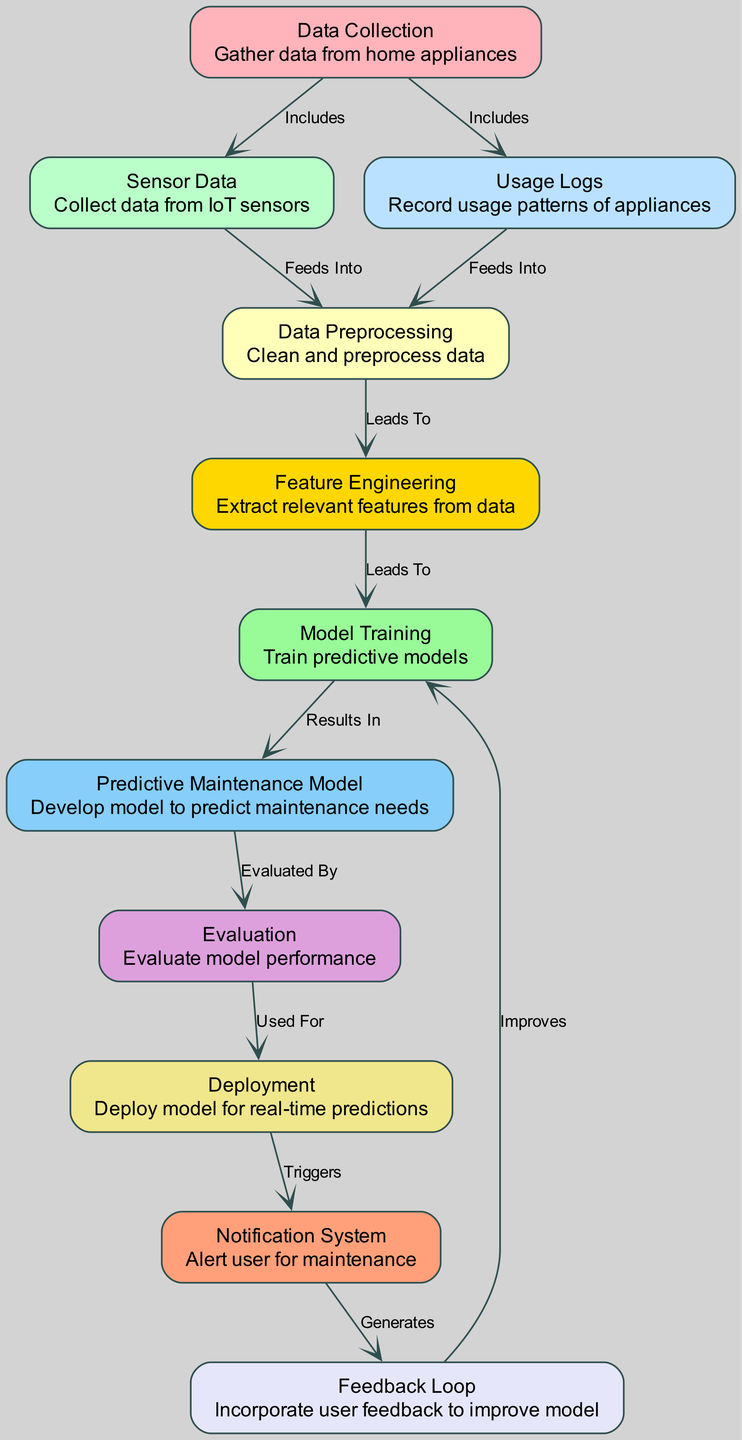What is the first step in the process? The first step in the diagram is labeled "Data Collection," which is where data is gathered from home appliances.
Answer: Data Collection How many nodes are exclusively related to data collection? The nodes "Sensor Data" and "Usage Logs" are both included under "Data Collection," indicating they are specifically related. Counting these gives us a total of two nodes.
Answer: 2 What does the "Data Preprocessing" node lead to? The diagram indicates that the "Data Preprocessing" node leads to the "Feature Engineering" node, meaning that after data is cleaned and preprocessed, the relevant features are extracted next.
Answer: Feature Engineering Which node evaluates the model performance? The "Evaluation" node is designated as the one that evaluates the performance of the predictive maintenance model according to the diagram.
Answer: Evaluation What triggers the notification system? The "Deployment" node triggers the "Notification System," indicating that once the model is deployed, the system will send alerts for maintenance needs.
Answer: Deployment Which two nodes feed into the "Data Preprocessing" node? The "Sensor Data" and "Usage Logs" nodes both feed into the "Data Preprocessing" node, meaning data from these sources is used for cleaning and preparation.
Answer: Sensor Data, Usage Logs How does the feedback loop impact model training? The "Feedback Loop" node improves the "Model Training" node, meaning the feedback received from users is utilized to enhance the predictive models over time.
Answer: Improves What is the output of the predictive maintenance model? The output is the "Predictive Maintenance Model," which develops predictions for when maintenance is needed based on the trained models.
Answer: Predictive Maintenance Model Which process involves cleaning and preprocessing for further use? The "Data Preprocessing" process involves cleaning and preparing the data for subsequent steps in the pipeline, ensuring quality data is used.
Answer: Data Preprocessing How many edges are present in the diagram? By counting the edges that connect the nodes, we find there are twelve edges showing relationships between different steps in the process.
Answer: 12 